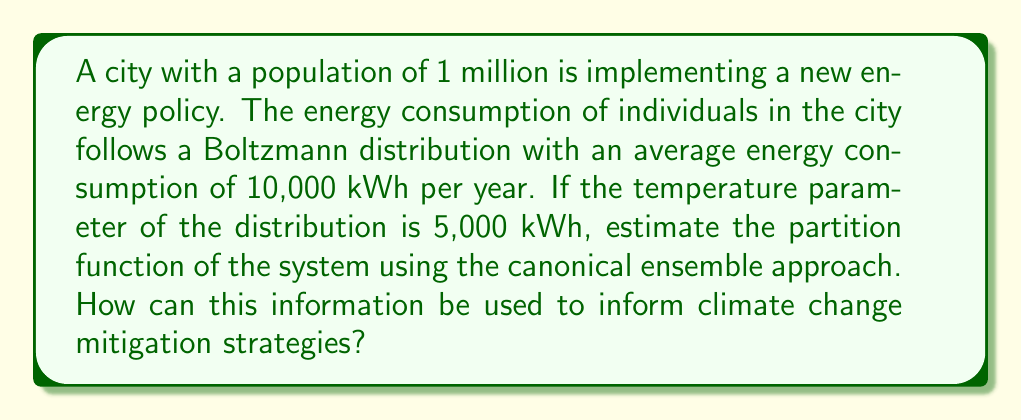Teach me how to tackle this problem. To solve this problem, we'll use the canonical ensemble approach from statistical mechanics:

1. The Boltzmann distribution is given by:
   $$P(E) = \frac{1}{Z} e^{-E/kT}$$
   where $Z$ is the partition function, $E$ is the energy, $k$ is Boltzmann's constant, and $T$ is temperature.

2. In this case, $kT$ is equivalent to the temperature parameter of 5,000 kWh.

3. The average energy $\langle E \rangle$ in the canonical ensemble is related to the partition function by:
   $$\langle E \rangle = -\frac{\partial \ln Z}{\partial \beta}$$
   where $\beta = \frac{1}{kT}$

4. We're given that $\langle E \rangle = 10,000$ kWh and $kT = 5,000$ kWh. Let's substitute these values:
   $$10,000 = -\frac{\partial \ln Z}{\partial (1/5,000)}$$

5. Simplifying:
   $$-50,000,000 = \frac{\partial \ln Z}{\partial (1/kT)}$$

6. Integrating both sides with respect to $1/kT$:
   $$\ln Z = -50,000,000 \cdot (1/kT) + C$$
   where $C$ is a constant of integration.

7. Taking the exponential of both sides:
   $$Z = e^{-50,000,000 \cdot (1/kT) + C} = A \cdot e^{-10 \cdot (1/kT)}$$
   where $A = e^C$ is a constant.

This result shows that the partition function has an exponential form with a characteristic energy of 10 times the temperature parameter.

For climate change mitigation strategies, this information can be used to:
1. Model the distribution of energy consumption in the population.
2. Predict how changes in policy (affecting the temperature parameter) might shift overall energy usage.
3. Identify high-impact interventions that could reduce the average energy consumption.
4. Set realistic targets for energy reduction based on the statistical properties of the distribution.
Answer: $Z = A \cdot e^{-10 \cdot (1/kT)}$, where $A$ is a constant and $kT = 5,000$ kWh. 